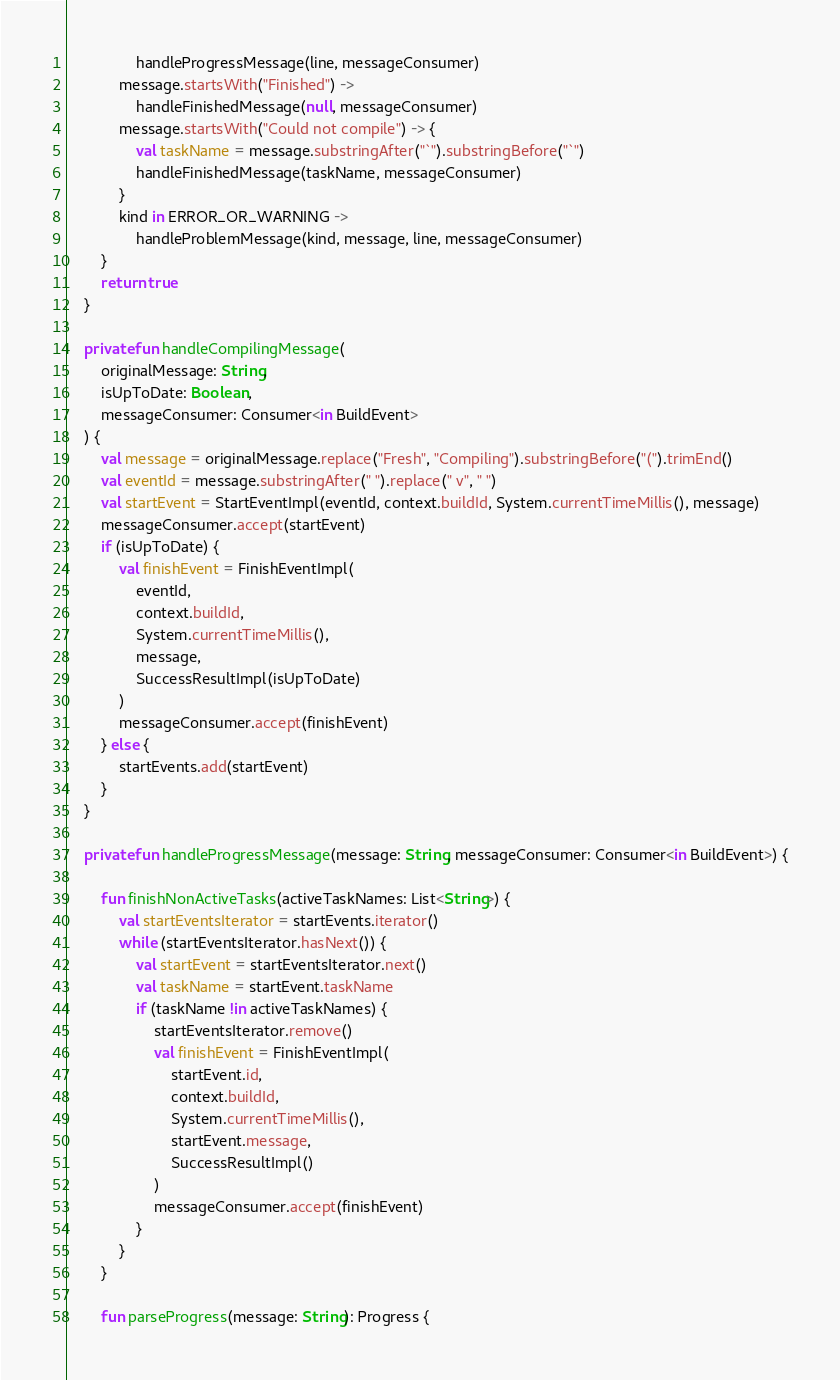Convert code to text. <code><loc_0><loc_0><loc_500><loc_500><_Kotlin_>                handleProgressMessage(line, messageConsumer)
            message.startsWith("Finished") ->
                handleFinishedMessage(null, messageConsumer)
            message.startsWith("Could not compile") -> {
                val taskName = message.substringAfter("`").substringBefore("`")
                handleFinishedMessage(taskName, messageConsumer)
            }
            kind in ERROR_OR_WARNING ->
                handleProblemMessage(kind, message, line, messageConsumer)
        }
        return true
    }

    private fun handleCompilingMessage(
        originalMessage: String,
        isUpToDate: Boolean,
        messageConsumer: Consumer<in BuildEvent>
    ) {
        val message = originalMessage.replace("Fresh", "Compiling").substringBefore("(").trimEnd()
        val eventId = message.substringAfter(" ").replace(" v", " ")
        val startEvent = StartEventImpl(eventId, context.buildId, System.currentTimeMillis(), message)
        messageConsumer.accept(startEvent)
        if (isUpToDate) {
            val finishEvent = FinishEventImpl(
                eventId,
                context.buildId,
                System.currentTimeMillis(),
                message,
                SuccessResultImpl(isUpToDate)
            )
            messageConsumer.accept(finishEvent)
        } else {
            startEvents.add(startEvent)
        }
    }

    private fun handleProgressMessage(message: String, messageConsumer: Consumer<in BuildEvent>) {

        fun finishNonActiveTasks(activeTaskNames: List<String>) {
            val startEventsIterator = startEvents.iterator()
            while (startEventsIterator.hasNext()) {
                val startEvent = startEventsIterator.next()
                val taskName = startEvent.taskName
                if (taskName !in activeTaskNames) {
                    startEventsIterator.remove()
                    val finishEvent = FinishEventImpl(
                        startEvent.id,
                        context.buildId,
                        System.currentTimeMillis(),
                        startEvent.message,
                        SuccessResultImpl()
                    )
                    messageConsumer.accept(finishEvent)
                }
            }
        }

        fun parseProgress(message: String): Progress {</code> 